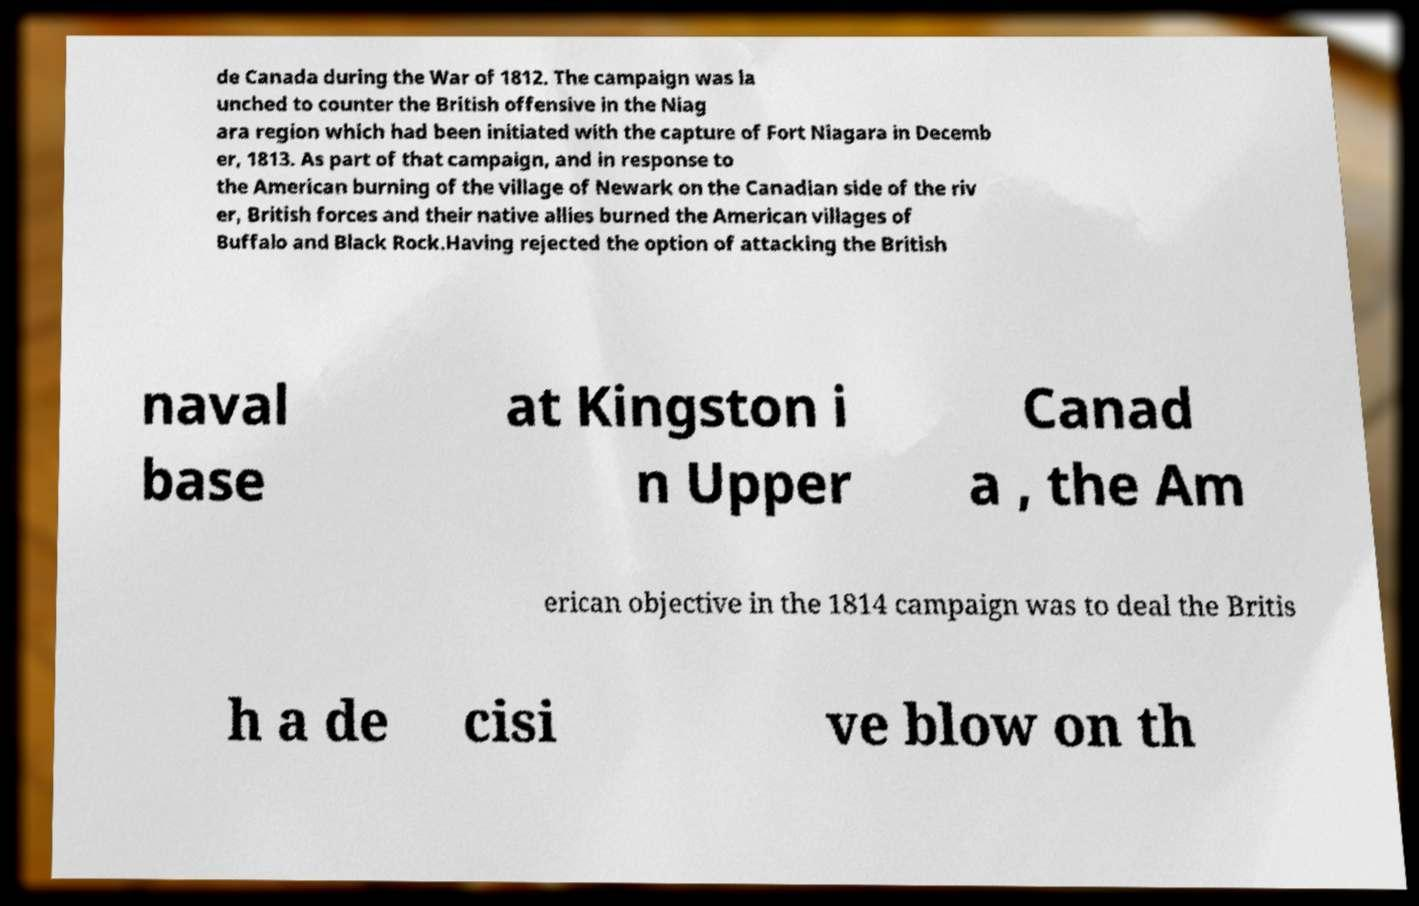For documentation purposes, I need the text within this image transcribed. Could you provide that? de Canada during the War of 1812. The campaign was la unched to counter the British offensive in the Niag ara region which had been initiated with the capture of Fort Niagara in Decemb er, 1813. As part of that campaign, and in response to the American burning of the village of Newark on the Canadian side of the riv er, British forces and their native allies burned the American villages of Buffalo and Black Rock.Having rejected the option of attacking the British naval base at Kingston i n Upper Canad a , the Am erican objective in the 1814 campaign was to deal the Britis h a de cisi ve blow on th 